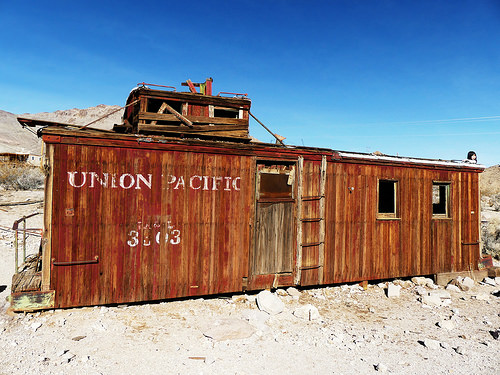<image>
Can you confirm if the inscription is on the floor? No. The inscription is not positioned on the floor. They may be near each other, but the inscription is not supported by or resting on top of the floor. 